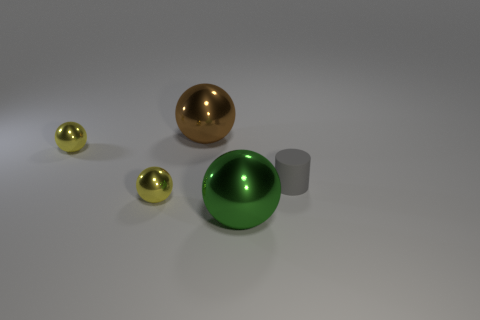Add 5 large rubber things. How many objects exist? 10 Subtract all balls. How many objects are left? 1 Subtract 1 brown spheres. How many objects are left? 4 Subtract all big metallic things. Subtract all yellow metallic objects. How many objects are left? 1 Add 1 small cylinders. How many small cylinders are left? 2 Add 3 small metal spheres. How many small metal spheres exist? 5 